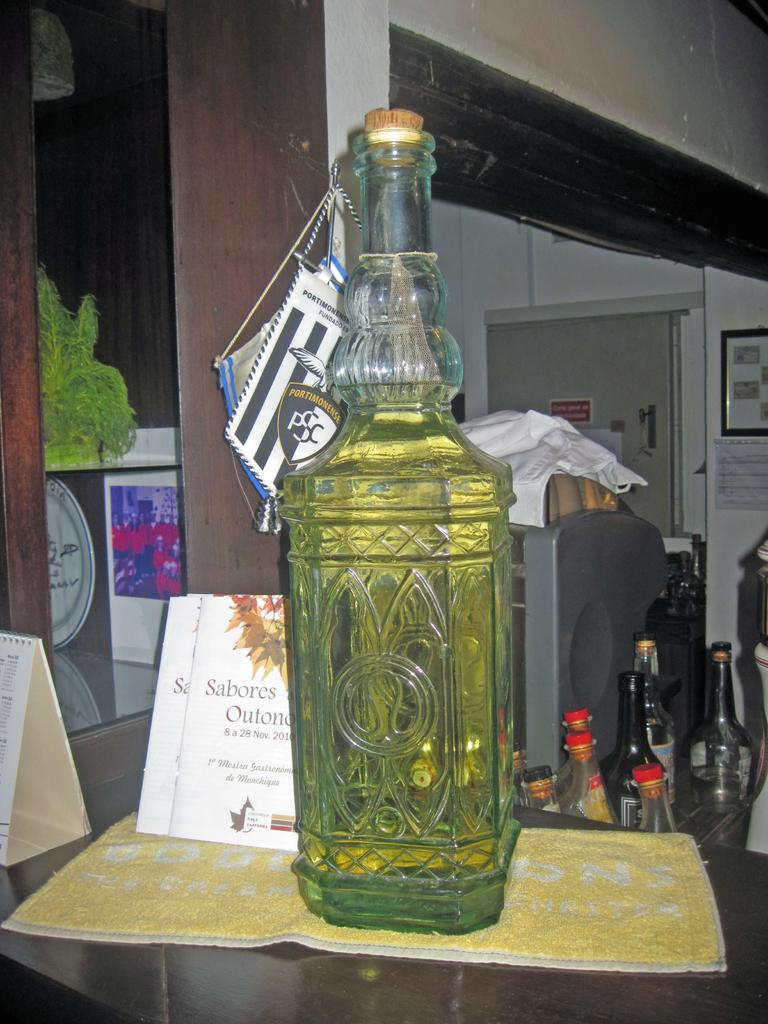What is on the table in the image? There is a bottle on the table in the image. What is inside the bottle? There is liquid in the bottle. How many bottles can be seen in the image? There are multiple bottles in the image. What architectural feature is present in the image? There is a pillar in the image. What is on the wall in the image? There is a photo frame on the wall. What type of ant can be seen climbing the pillar in the image? There are no ants present in the image, and therefore no such activity can be observed. What reward is being given to the person in the photo frame? There is no indication of a reward in the image, as the focus is on the photo frame itself. 